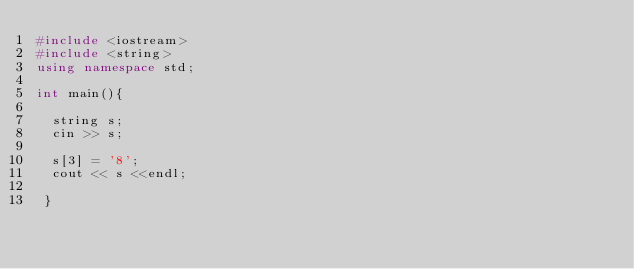<code> <loc_0><loc_0><loc_500><loc_500><_C++_>#include <iostream>
#include <string>
using namespace std;

int main(){

  string s;
  cin >> s;

  s[3] = '8';
  cout << s <<endl;

 }</code> 